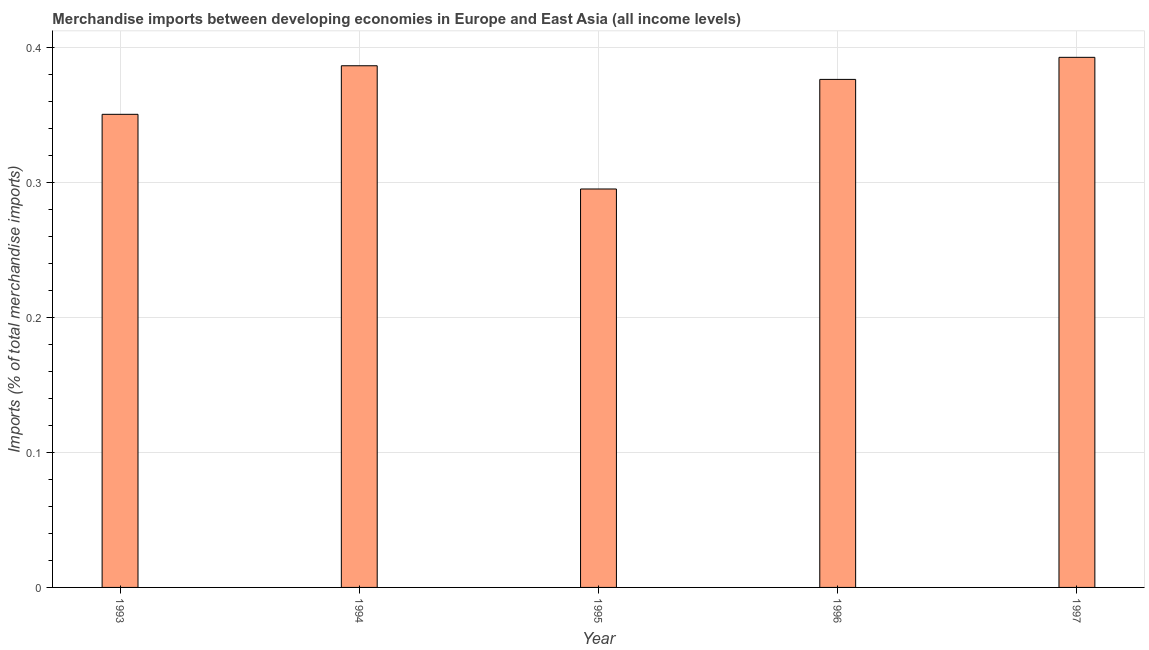Does the graph contain grids?
Ensure brevity in your answer.  Yes. What is the title of the graph?
Give a very brief answer. Merchandise imports between developing economies in Europe and East Asia (all income levels). What is the label or title of the Y-axis?
Offer a very short reply. Imports (% of total merchandise imports). What is the merchandise imports in 1995?
Provide a succinct answer. 0.3. Across all years, what is the maximum merchandise imports?
Offer a very short reply. 0.39. Across all years, what is the minimum merchandise imports?
Your answer should be very brief. 0.3. What is the sum of the merchandise imports?
Your answer should be compact. 1.8. What is the difference between the merchandise imports in 1993 and 1994?
Offer a very short reply. -0.04. What is the average merchandise imports per year?
Give a very brief answer. 0.36. What is the median merchandise imports?
Make the answer very short. 0.38. Do a majority of the years between 1994 and 1996 (inclusive) have merchandise imports greater than 0.16 %?
Your answer should be very brief. Yes. Is the merchandise imports in 1995 less than that in 1996?
Offer a terse response. Yes. What is the difference between the highest and the second highest merchandise imports?
Make the answer very short. 0.01. What is the difference between the highest and the lowest merchandise imports?
Offer a very short reply. 0.1. How many bars are there?
Keep it short and to the point. 5. What is the difference between two consecutive major ticks on the Y-axis?
Keep it short and to the point. 0.1. Are the values on the major ticks of Y-axis written in scientific E-notation?
Provide a short and direct response. No. What is the Imports (% of total merchandise imports) in 1993?
Your response must be concise. 0.35. What is the Imports (% of total merchandise imports) in 1994?
Offer a terse response. 0.39. What is the Imports (% of total merchandise imports) in 1995?
Give a very brief answer. 0.3. What is the Imports (% of total merchandise imports) in 1996?
Offer a very short reply. 0.38. What is the Imports (% of total merchandise imports) of 1997?
Your answer should be very brief. 0.39. What is the difference between the Imports (% of total merchandise imports) in 1993 and 1994?
Give a very brief answer. -0.04. What is the difference between the Imports (% of total merchandise imports) in 1993 and 1995?
Your answer should be compact. 0.06. What is the difference between the Imports (% of total merchandise imports) in 1993 and 1996?
Your answer should be compact. -0.03. What is the difference between the Imports (% of total merchandise imports) in 1993 and 1997?
Give a very brief answer. -0.04. What is the difference between the Imports (% of total merchandise imports) in 1994 and 1995?
Make the answer very short. 0.09. What is the difference between the Imports (% of total merchandise imports) in 1994 and 1996?
Your answer should be compact. 0.01. What is the difference between the Imports (% of total merchandise imports) in 1994 and 1997?
Keep it short and to the point. -0.01. What is the difference between the Imports (% of total merchandise imports) in 1995 and 1996?
Provide a succinct answer. -0.08. What is the difference between the Imports (% of total merchandise imports) in 1995 and 1997?
Offer a very short reply. -0.1. What is the difference between the Imports (% of total merchandise imports) in 1996 and 1997?
Keep it short and to the point. -0.02. What is the ratio of the Imports (% of total merchandise imports) in 1993 to that in 1994?
Your answer should be very brief. 0.91. What is the ratio of the Imports (% of total merchandise imports) in 1993 to that in 1995?
Ensure brevity in your answer.  1.19. What is the ratio of the Imports (% of total merchandise imports) in 1993 to that in 1997?
Your response must be concise. 0.89. What is the ratio of the Imports (% of total merchandise imports) in 1994 to that in 1995?
Offer a terse response. 1.31. What is the ratio of the Imports (% of total merchandise imports) in 1994 to that in 1996?
Give a very brief answer. 1.03. What is the ratio of the Imports (% of total merchandise imports) in 1995 to that in 1996?
Give a very brief answer. 0.78. What is the ratio of the Imports (% of total merchandise imports) in 1995 to that in 1997?
Your answer should be compact. 0.75. What is the ratio of the Imports (% of total merchandise imports) in 1996 to that in 1997?
Make the answer very short. 0.96. 